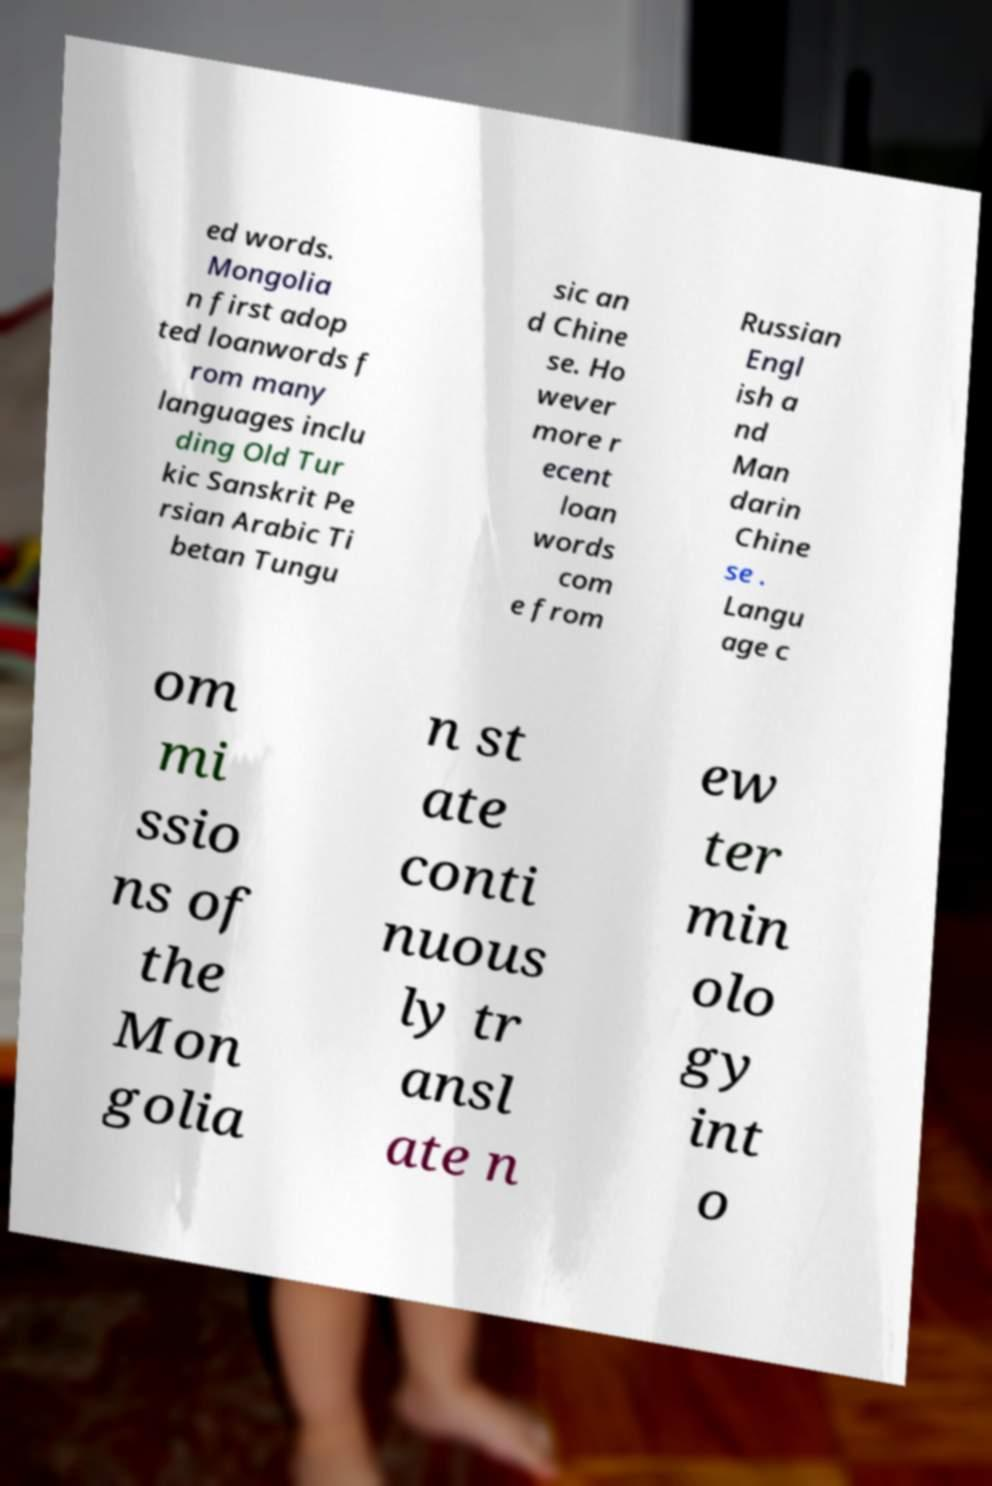Can you accurately transcribe the text from the provided image for me? ed words. Mongolia n first adop ted loanwords f rom many languages inclu ding Old Tur kic Sanskrit Pe rsian Arabic Ti betan Tungu sic an d Chine se. Ho wever more r ecent loan words com e from Russian Engl ish a nd Man darin Chine se . Langu age c om mi ssio ns of the Mon golia n st ate conti nuous ly tr ansl ate n ew ter min olo gy int o 